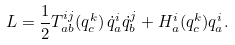<formula> <loc_0><loc_0><loc_500><loc_500>L = \frac { 1 } { 2 } T _ { a b } ^ { i j } ( q ^ { k } _ { c } ) \, \dot { q } _ { a } ^ { i } \dot { q } _ { b } ^ { j } + H ^ { i } _ { a } ( q ^ { k } _ { c } ) q ^ { i } _ { a } .</formula> 